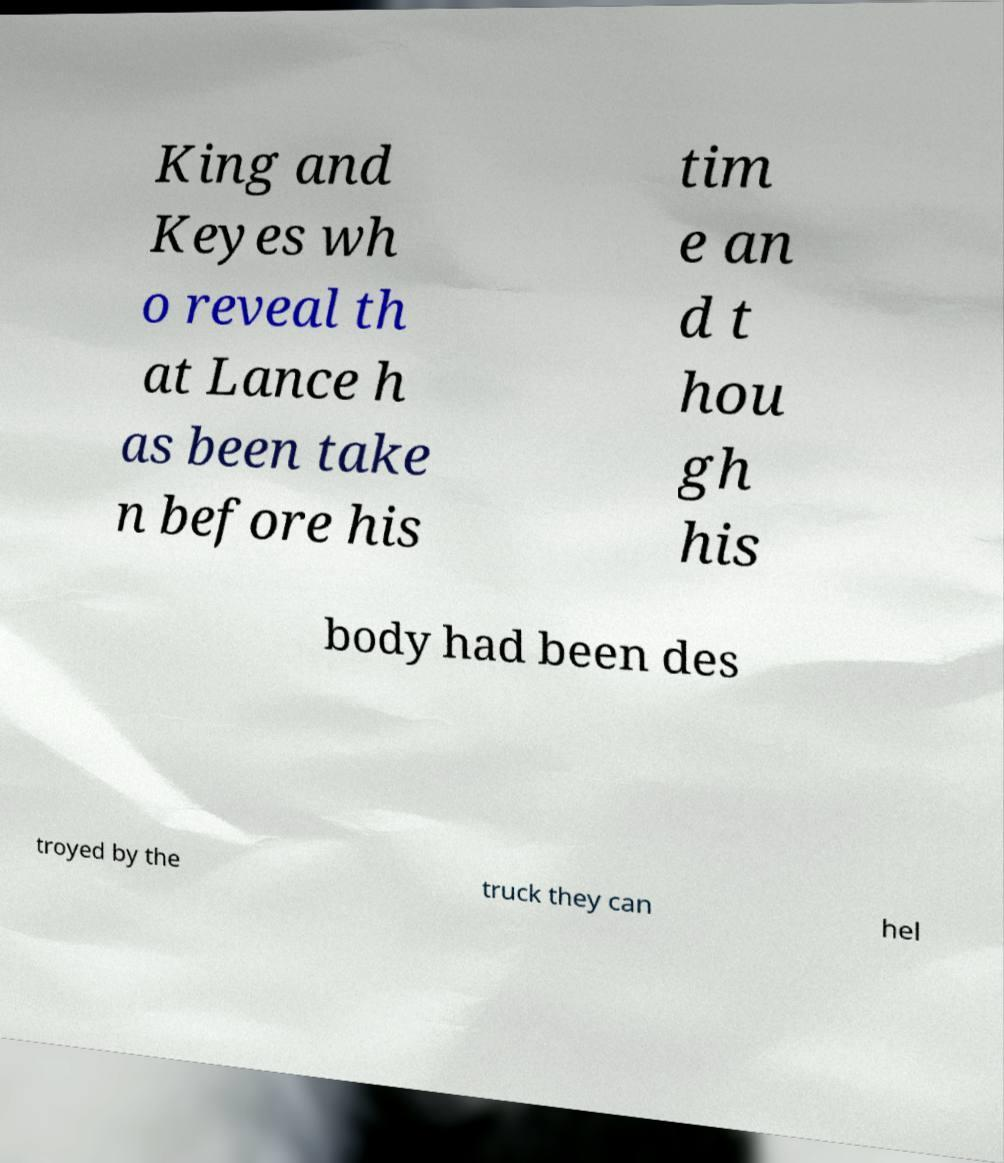Could you assist in decoding the text presented in this image and type it out clearly? King and Keyes wh o reveal th at Lance h as been take n before his tim e an d t hou gh his body had been des troyed by the truck they can hel 